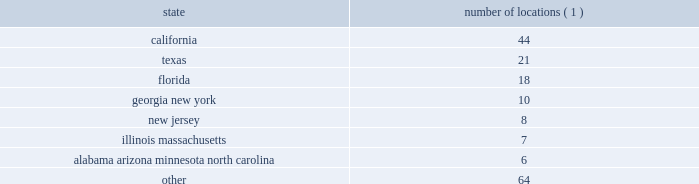2022 the ability to identify suitable acquisition candidates and the ability to finance such acquisitions , which depends upon the availability of adequate cash reserves from operations or of acceptable financing terms and the variability of our stock price ; 2022 our ability to integrate any acquired business 2019 operations , services , clients , and personnel ; 2022 the effect of our substantial leverage , which may limit the funds available to make acquisitions and invest in our business ; 2022 changes in , or the failure to comply with , government regulations , including privacy regulations ; and 2022 other risks detailed elsewhere in this risk factors section and in our other filings with the securities and exchange commission .
We are not under any obligation ( and expressly disclaim any such obligation ) to update or alter our forward- looking statements , whether as a result of new information , future events or otherwise .
You should carefully consider the possibility that actual results may differ materially from our forward-looking statements .
Item 1b .
Unresolved staff comments .
Item 2 .
Properties .
Our corporate headquarters are located in jacksonville , florida , in an owned facility .
Fnf occupies and pays us rent for approximately 86000 square feet in this facility .
We lease office space as follows : number of locations ( 1 ) .
( 1 ) represents the number of locations in each state listed .
We also lease approximately 72 locations outside the united states .
We believe our properties are adequate for our business as presently conducted .
Item 3 .
Legal proceedings .
In the ordinary course of business , the company is involved in various pending and threatened litigation matters related to operations , some of which include claims for punitive or exemplary damages .
The company believes that no actions , other than the matters listed below , depart from customary litigation incidental to its business .
As background to the disclosure below , please note the following : 2022 these matters raise difficult and complicated factual and legal issues and are subject to many uncertainties and complexities .
2022 the company reviews these matters on an on-going basis and follows the provisions of statement of financial accounting standards no .
5 , accounting for contingencies ( 201csfas 5 201d ) , when making accrual and disclosure decisions .
When assessing reasonably possible and probable outcomes , the company bases decisions on the assessment of the ultimate outcome following all appeals. .
What percentage of total leased locations are located in united states? 
Computations: (64 / (72 + 64))
Answer: 0.47059. 